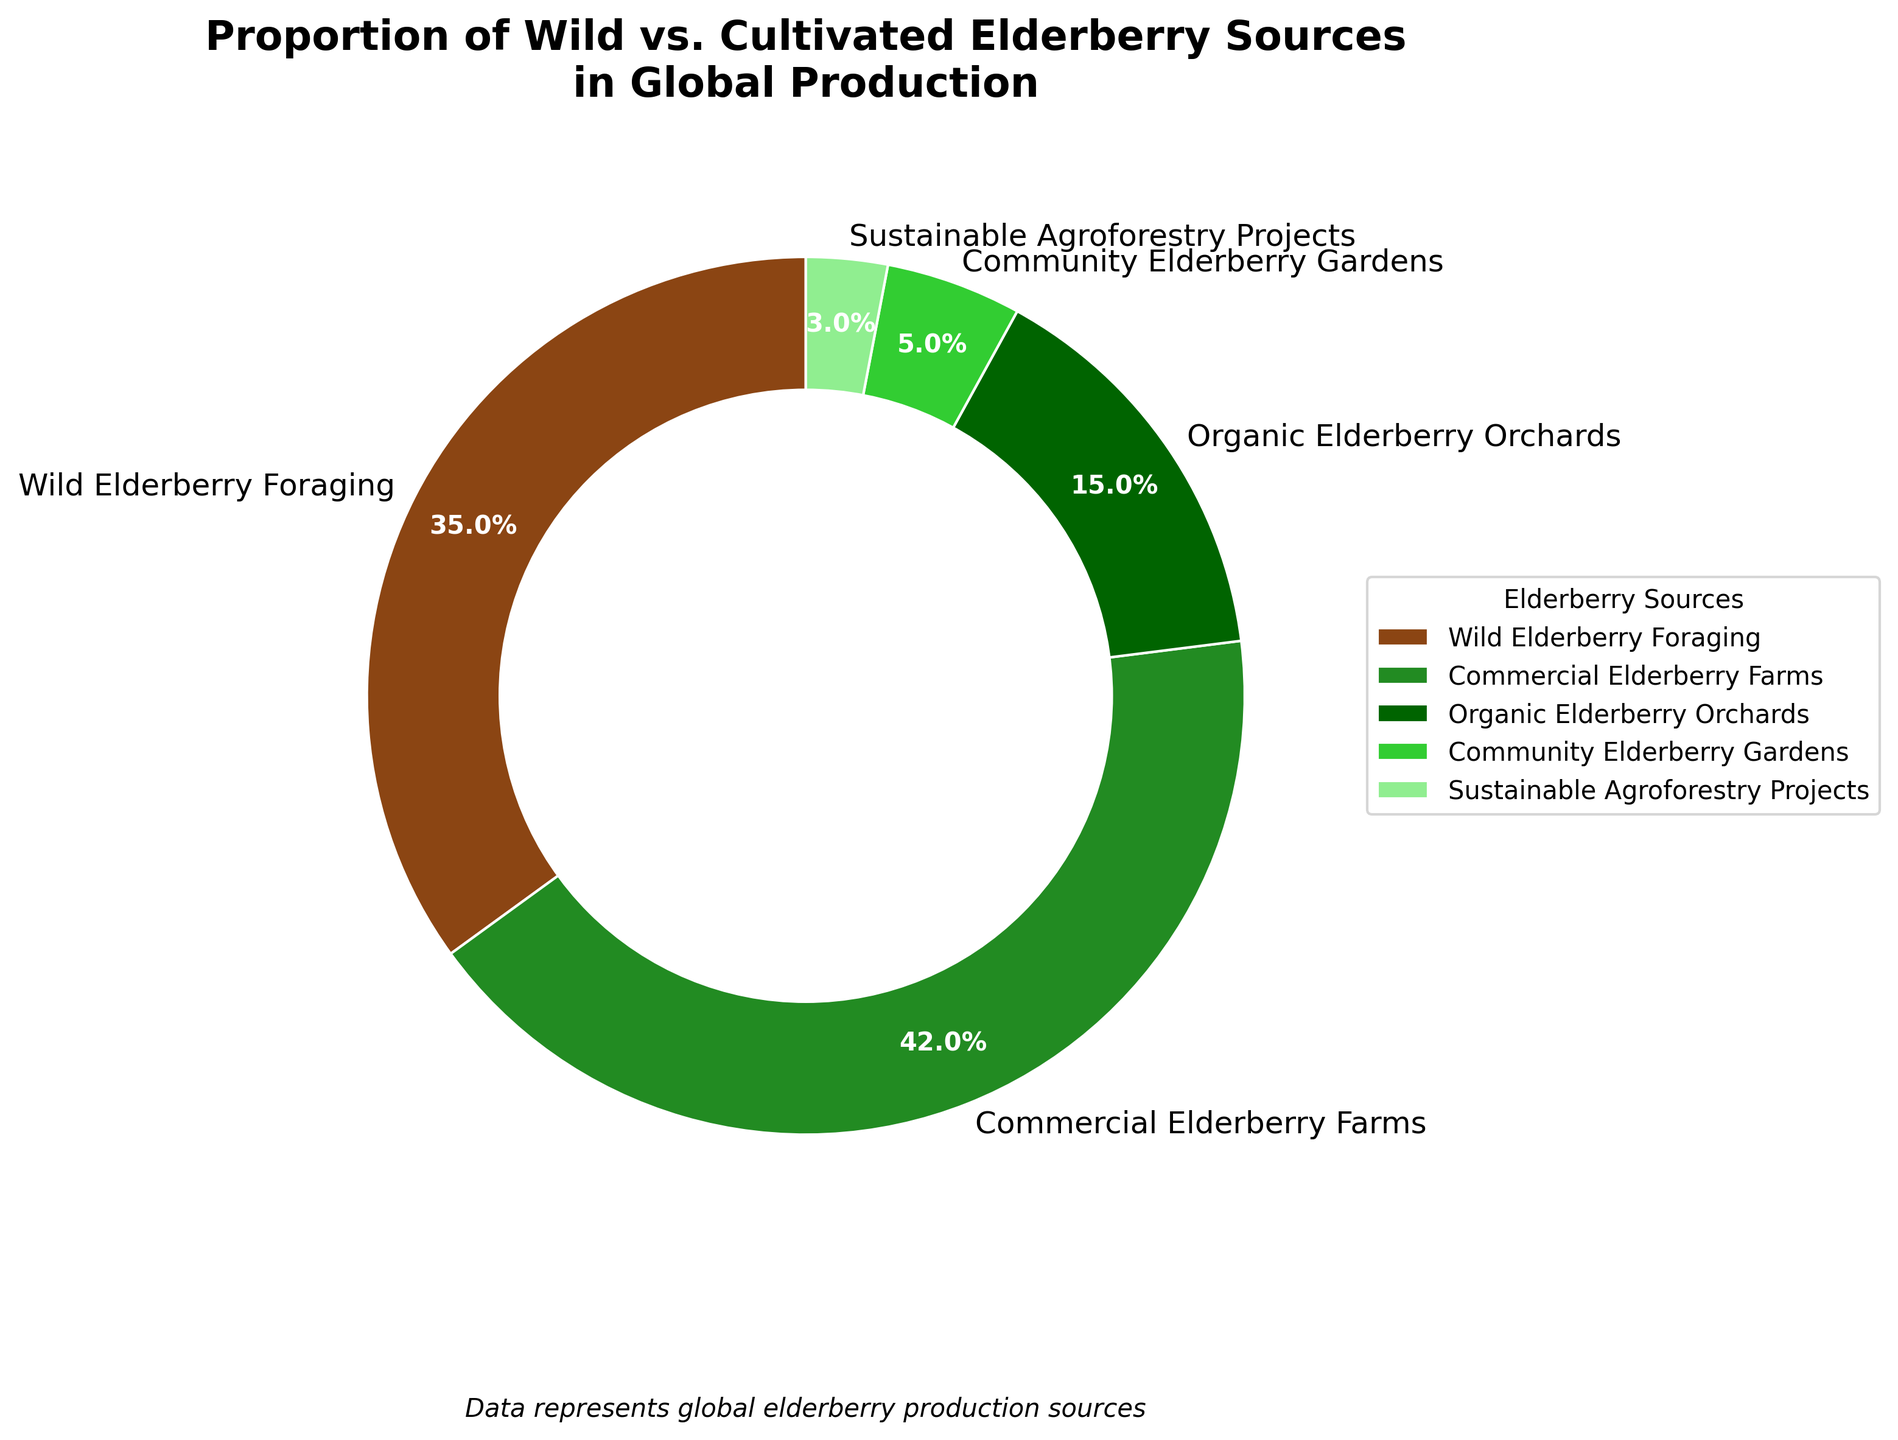What is the largest source of elderberry production? The largest source can be identified by the portion of the pie chart that has the highest percentage. The segment labeled "Commercial Elderberry Farms" constitutes 42%, which is the highest value among all the categories.
Answer: Commercial Elderberry Farms Which source has the lowest contribution to global elderberry production? To find the source with the lowest contribution, look for the smallest slice in the pie chart. The segment labeled "Sustainable Agroforestry Projects" is the smallest with 3%.
Answer: Sustainable Agroforestry Projects What is the combined percentage of elderberries sourced from organic elderberry orchards and community elderberry gardens? Add the percentages of the two categories: "Organic Elderberry Orchards" (15%) and "Community Elderberry Gardens" (5%). The combined percentage is 15% + 5% = 20%.
Answer: 20% How much larger is the percentage of wild elderberry foraging compared to sustainable agroforestry projects? Subtract the percentage of "Sustainable Agroforestry Projects" (3%) from "Wild Elderberry Foraging" (35%). The difference is 35% - 3% = 32%.
Answer: 32% Is the proportion of commercial elderberry farms greater than the sum of organic elderberry orchards and community elderberry gardens? Compare the percentage of "Commercial Elderberry Farms" (42%) to the combined percentage of "Organic Elderberry Orchards" (15%) and "Community Elderberry Gardens" (5%), which sums to 20%. Since 42% is greater than 20%, the statement is true.
Answer: Yes How do the contributions of community elderberry gardens and sustainable agroforestry projects compare? Compare the percentages of "Community Elderberry Gardens" (5%) and "Sustainable Agroforestry Projects" (3%). Community Elderberry Gardens has a higher percentage than Sustainable Agroforestry Projects.
Answer: Community Elderberry Gardens has a higher percentage Which elderberry source occupies the middle proportion in the pie chart when ordering by size? When ordered by size: Sustainable Agroforestry Projects (3%), Community Elderberry Gardens (5%), Organic Elderberry Orchards (15%), Wild Elderberry Foraging (35%), and Commercial Elderberry Farms (42%), the middle value is "Organic Elderberry Orchards" which has a 15% share.
Answer: Organic Elderberry Orchards What is the difference in percentage between the largest and smallest sources of elderberries? Subtract the percentage of the smallest source "Sustainable Agroforestry Projects" (3%) from the largest source "Commercial Elderberry Farms" (42%). The difference is 42% - 3% = 39%.
Answer: 39% What color represents the wild elderberry foraging source in the pie chart? Refer to the segment labeled "Wild Elderberry Foraging" in the pie chart, which is visually represented with a brown color.
Answer: Brown 